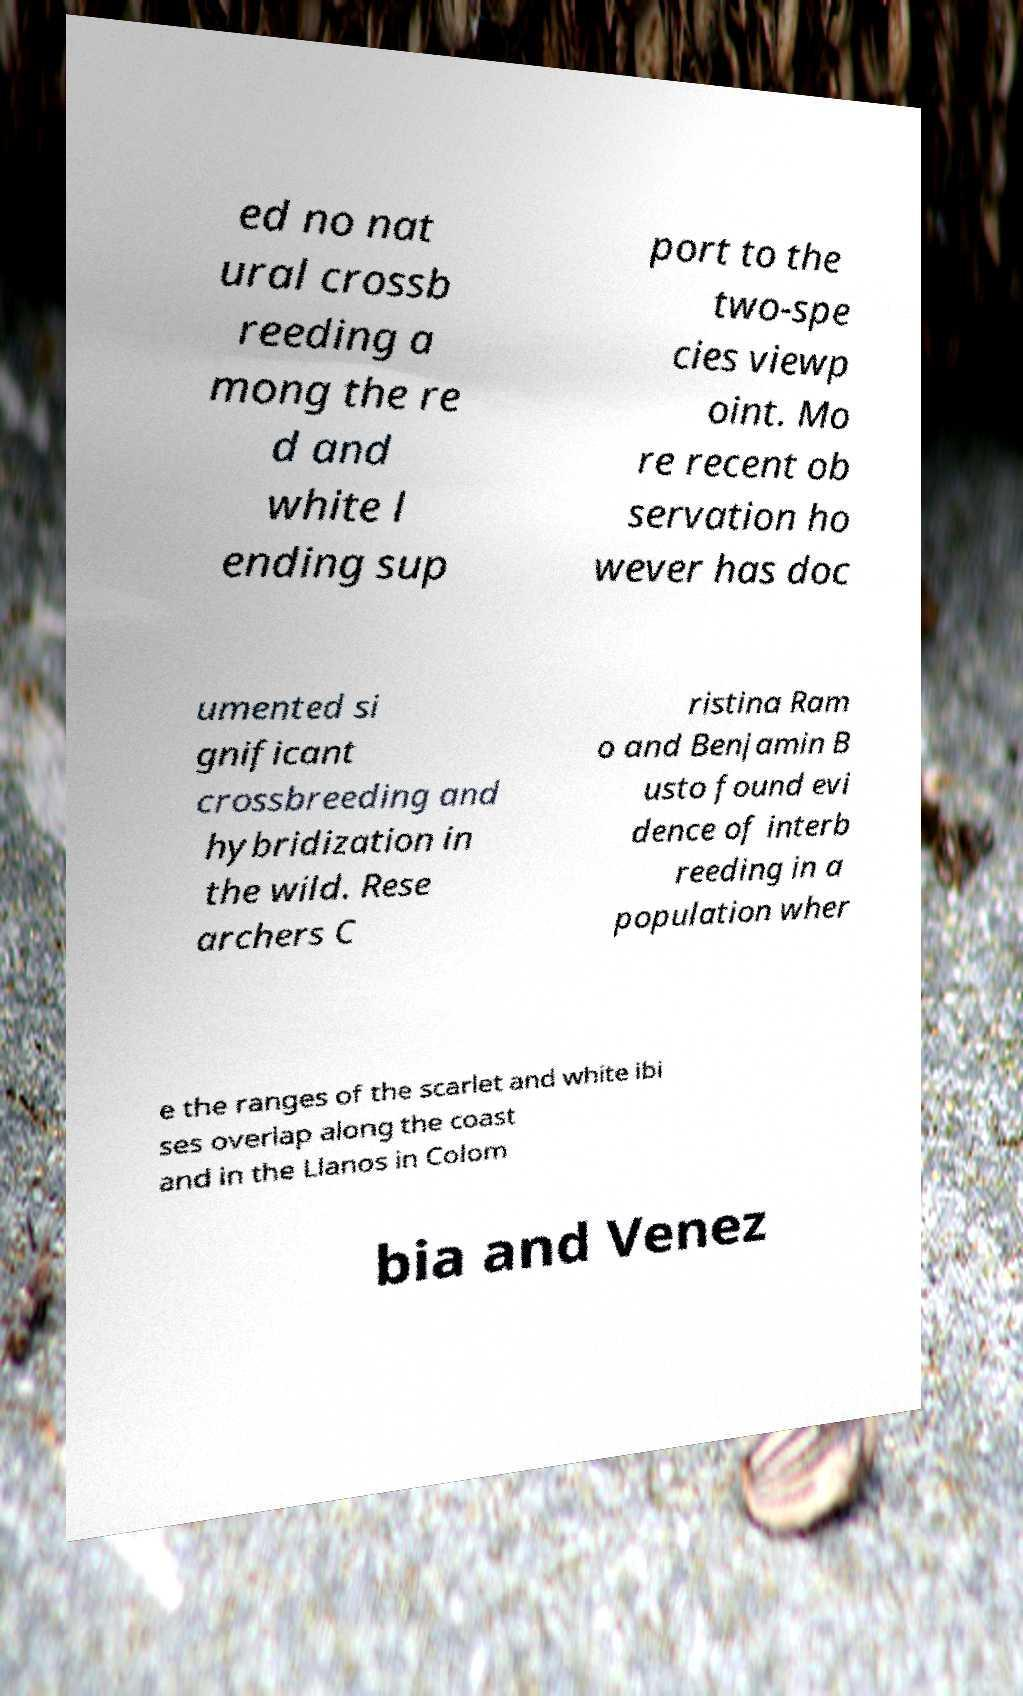Please read and relay the text visible in this image. What does it say? ed no nat ural crossb reeding a mong the re d and white l ending sup port to the two-spe cies viewp oint. Mo re recent ob servation ho wever has doc umented si gnificant crossbreeding and hybridization in the wild. Rese archers C ristina Ram o and Benjamin B usto found evi dence of interb reeding in a population wher e the ranges of the scarlet and white ibi ses overlap along the coast and in the Llanos in Colom bia and Venez 